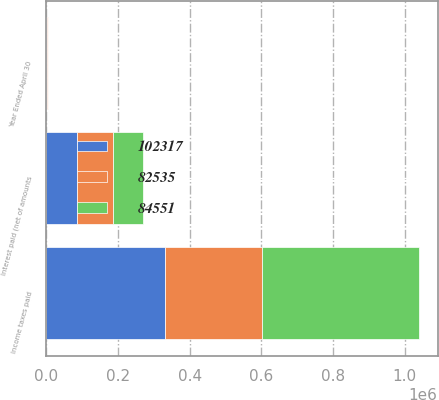Convert chart to OTSL. <chart><loc_0><loc_0><loc_500><loc_500><stacked_bar_chart><ecel><fcel>Year Ended April 30<fcel>Income taxes paid<fcel>Interest paid (net of amounts<nl><fcel>82535<fcel>2006<fcel>270540<fcel>102317<nl><fcel>84551<fcel>2005<fcel>437427<fcel>82535<nl><fcel>102317<fcel>2004<fcel>331635<fcel>84551<nl></chart> 